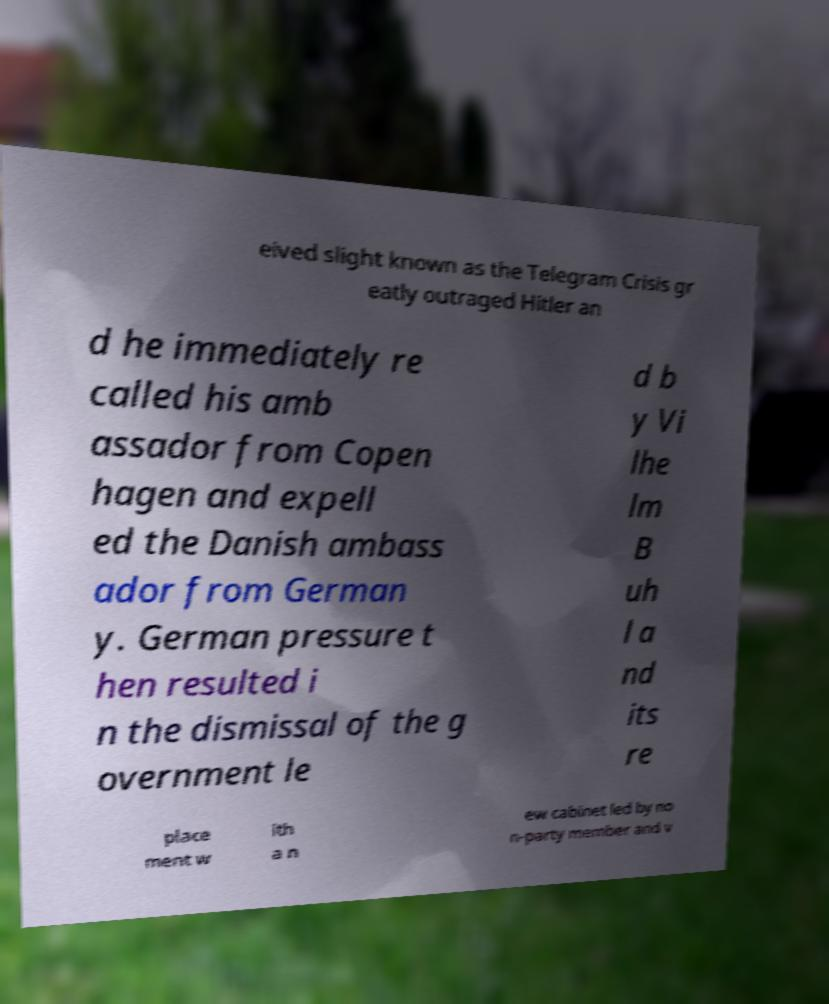Can you accurately transcribe the text from the provided image for me? eived slight known as the Telegram Crisis gr eatly outraged Hitler an d he immediately re called his amb assador from Copen hagen and expell ed the Danish ambass ador from German y. German pressure t hen resulted i n the dismissal of the g overnment le d b y Vi lhe lm B uh l a nd its re place ment w ith a n ew cabinet led by no n-party member and v 